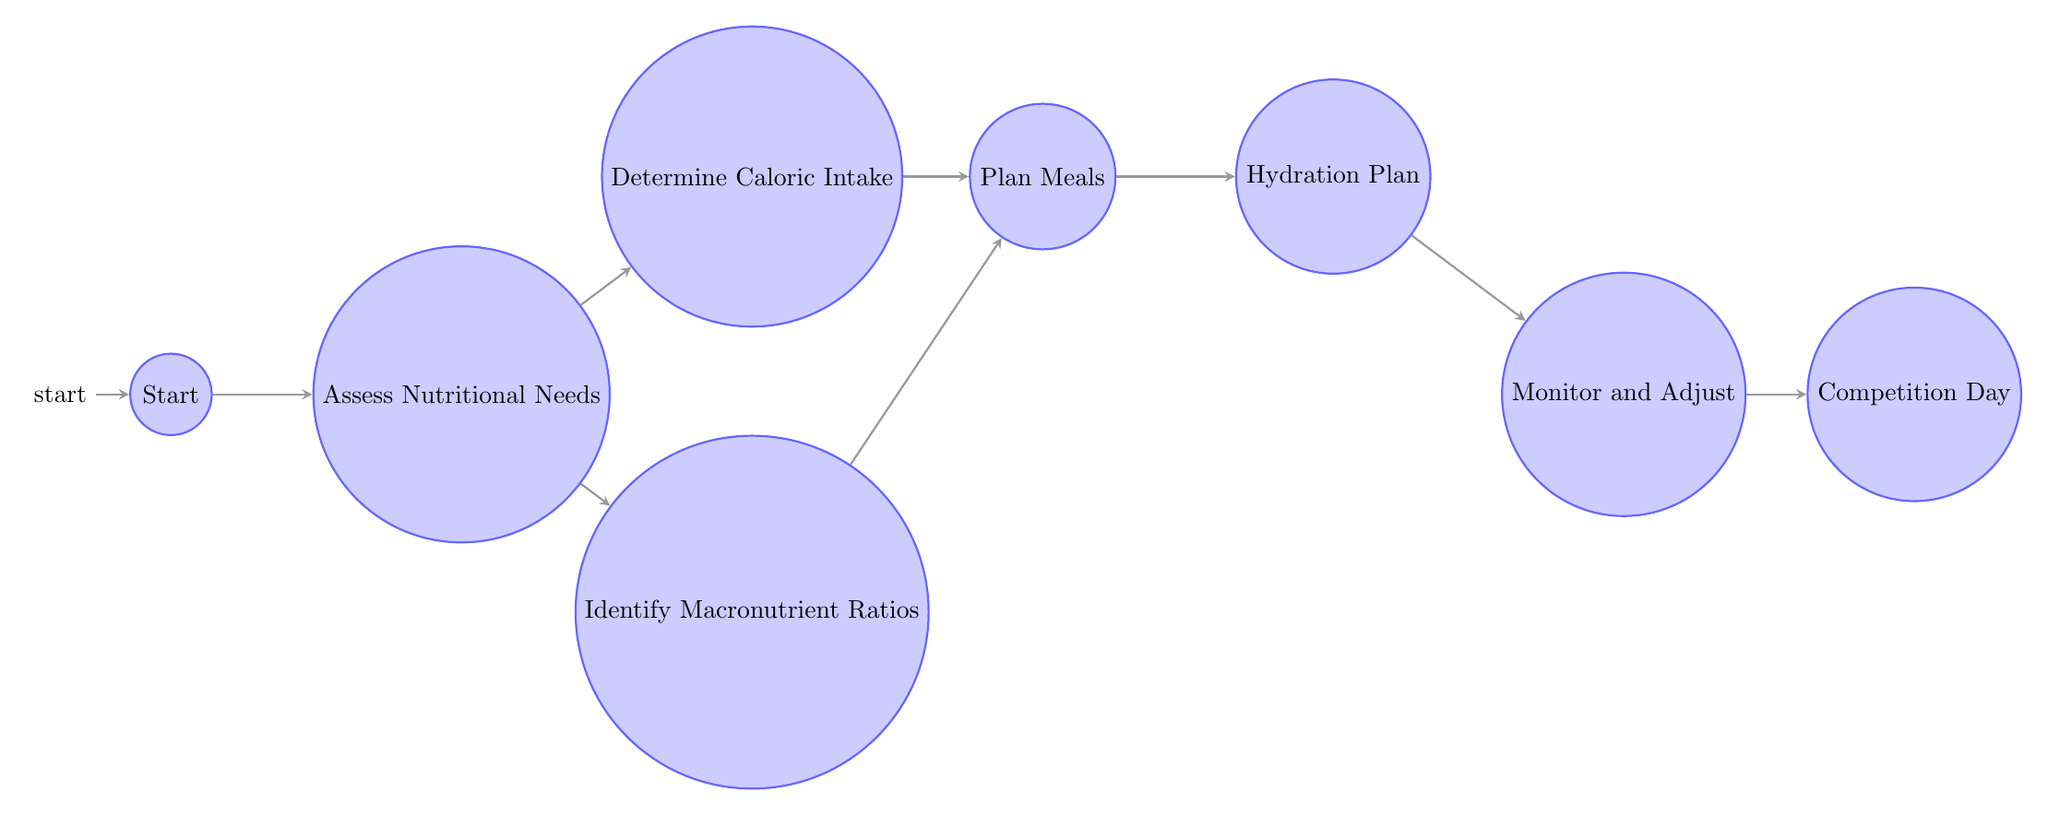What is the first state in the Finite State Machine? The diagram indicates that the first state is labeled 'Start', which is the initial node from where the process begins.
Answer: Start How many nodes are in the diagram? By counting each state represented in the diagram, we identify eight distinct states: Start, Assess Nutritional Needs, Determine Caloric Intake, Identify Macronutrient Ratios, Plan Meals, Hydration Plan, Monitor and Adjust, and Competition Day. Therefore, there are a total of eight nodes.
Answer: 8 What state comes after 'Assess Nutritional Needs'? Looking at the transitions in the diagram, we see that after 'Assess Nutritional Needs', the process can transition to either 'Determine Caloric Intake' or 'Identify Macronutrient Ratios'.
Answer: Determine Caloric Intake or Identify Macronutrient Ratios How many actions are listed under 'Breakfast'? The state 'Breakfast' includes four specific actions: 'Choose Protein Source', 'Choose Carbohydrate Source', 'Include Healthy Fats', and 'Add Vitamins and Minerals'. Therefore, the total number of actions is four.
Answer: 4 Which state directly leads to 'Competition Day'? Following the transitions in the diagram, we find that 'Monitor and Adjust' is the only state that leads directly to 'Competition Day'. This indicates a clear progression from monitoring dietary needs to preparing for competition.
Answer: Monitor and Adjust What is a required action in the 'Hydration Plan'? The 'Hydration Plan' encompasses three actions: 'Daily Water Intake', 'Electrolyte Balance', and 'Supplementation'. These actions focus on ensuring adequate hydration and nutrient balance.
Answer: Daily Water Intake, Electrolyte Balance, or Supplementation What is the last state in the Finite State Machine? The diagram culminates at 'Competition Day', which represents the end of the process as it involves preparing for competition. This identification of the final outcome state is based on the diagram's layout and flow.
Answer: Competition Day Which states lead to the 'Plan Meals' state? The states 'Determine Caloric Intake' and 'Identify Macronutrient Ratios' both transition to 'Plan Meals', indicating that information from these two states is necessary for meal planning.
Answer: Determine Caloric Intake and Identify Macronutrient Ratios What actions are included in the 'Lunch' state? Similar to the 'Breakfast' state, 'Lunch' consists of the same four actions: 'Choose Protein Source', 'Choose Carbohydrate Source', 'Include Healthy Fats', and 'Add Vitamins and Minerals'.
Answer: Choose Protein Source, Choose Carbohydrate Source, Include Healthy Fats, Add Vitamins and Minerals 